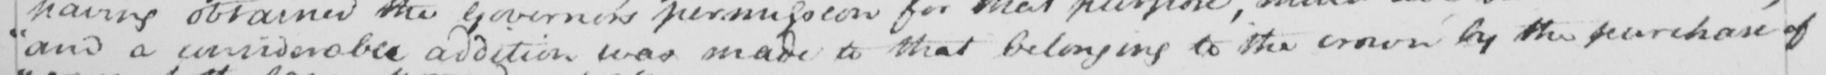What is written in this line of handwriting? " and a considerable addition was made to that belonging to the crown by the purchase of 